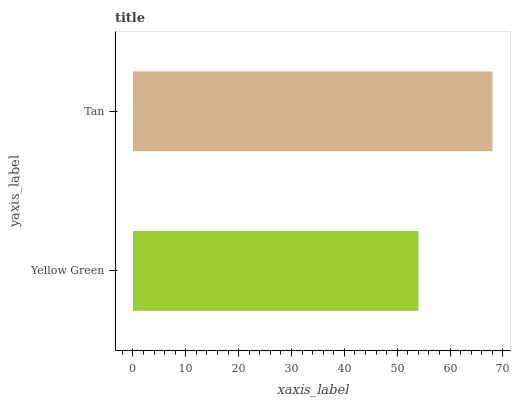Is Yellow Green the minimum?
Answer yes or no. Yes. Is Tan the maximum?
Answer yes or no. Yes. Is Tan the minimum?
Answer yes or no. No. Is Tan greater than Yellow Green?
Answer yes or no. Yes. Is Yellow Green less than Tan?
Answer yes or no. Yes. Is Yellow Green greater than Tan?
Answer yes or no. No. Is Tan less than Yellow Green?
Answer yes or no. No. Is Tan the high median?
Answer yes or no. Yes. Is Yellow Green the low median?
Answer yes or no. Yes. Is Yellow Green the high median?
Answer yes or no. No. Is Tan the low median?
Answer yes or no. No. 